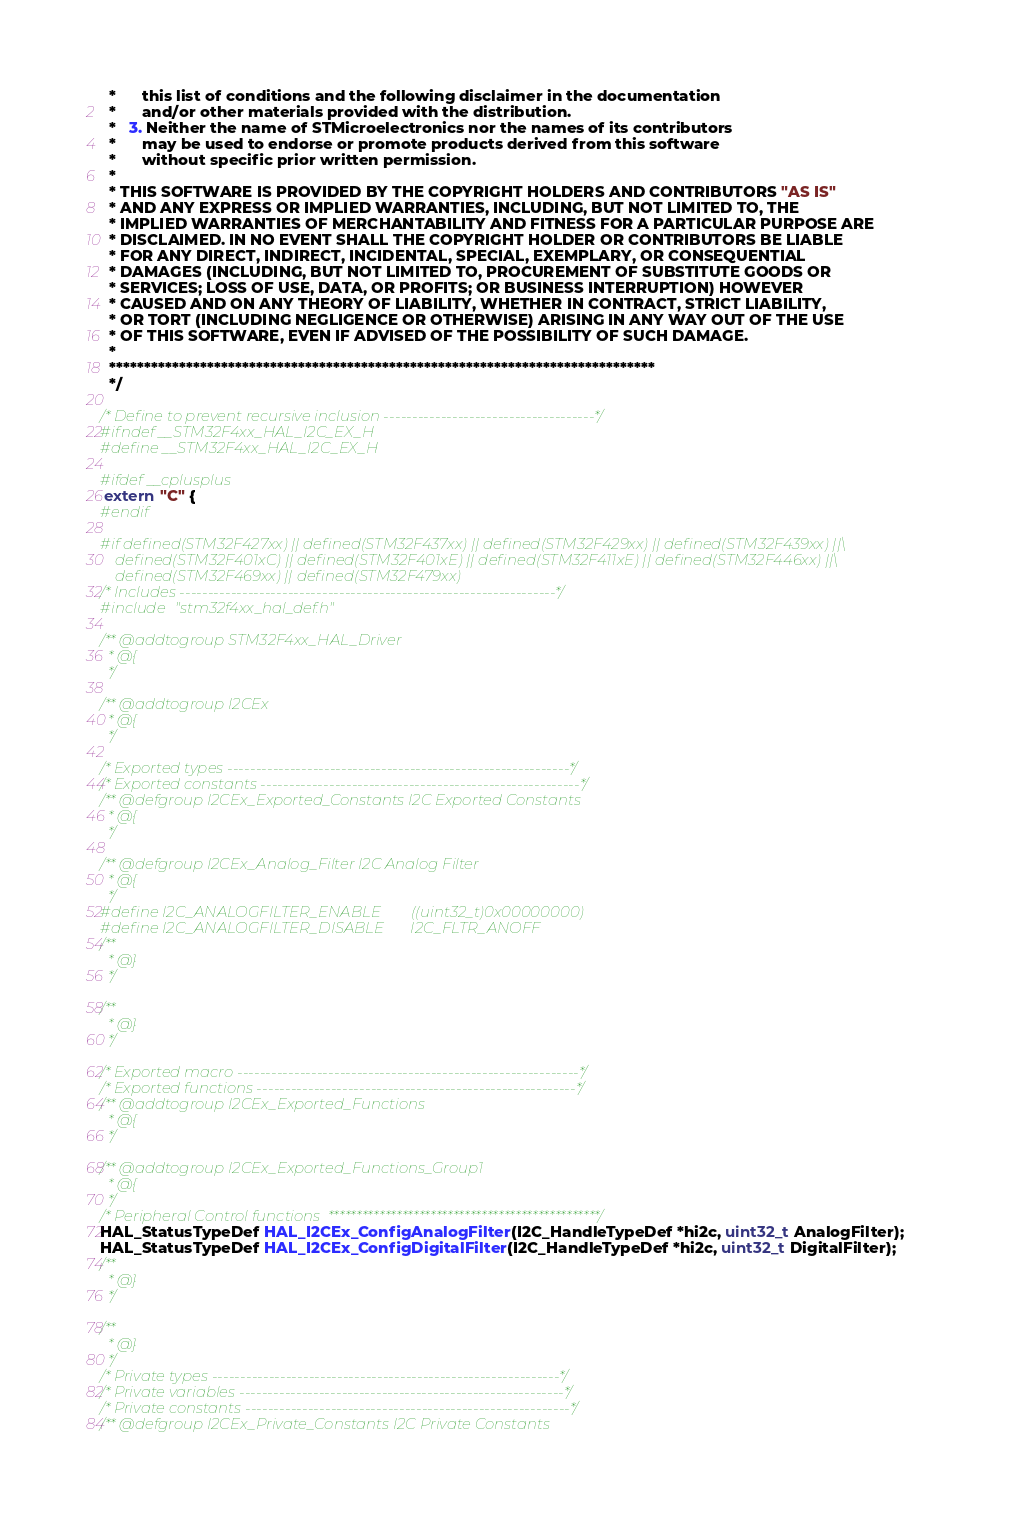Convert code to text. <code><loc_0><loc_0><loc_500><loc_500><_C_>  *      this list of conditions and the following disclaimer in the documentation
  *      and/or other materials provided with the distribution.
  *   3. Neither the name of STMicroelectronics nor the names of its contributors
  *      may be used to endorse or promote products derived from this software
  *      without specific prior written permission.
  *
  * THIS SOFTWARE IS PROVIDED BY THE COPYRIGHT HOLDERS AND CONTRIBUTORS "AS IS"
  * AND ANY EXPRESS OR IMPLIED WARRANTIES, INCLUDING, BUT NOT LIMITED TO, THE
  * IMPLIED WARRANTIES OF MERCHANTABILITY AND FITNESS FOR A PARTICULAR PURPOSE ARE
  * DISCLAIMED. IN NO EVENT SHALL THE COPYRIGHT HOLDER OR CONTRIBUTORS BE LIABLE
  * FOR ANY DIRECT, INDIRECT, INCIDENTAL, SPECIAL, EXEMPLARY, OR CONSEQUENTIAL
  * DAMAGES (INCLUDING, BUT NOT LIMITED TO, PROCUREMENT OF SUBSTITUTE GOODS OR
  * SERVICES; LOSS OF USE, DATA, OR PROFITS; OR BUSINESS INTERRUPTION) HOWEVER
  * CAUSED AND ON ANY THEORY OF LIABILITY, WHETHER IN CONTRACT, STRICT LIABILITY,
  * OR TORT (INCLUDING NEGLIGENCE OR OTHERWISE) ARISING IN ANY WAY OUT OF THE USE
  * OF THIS SOFTWARE, EVEN IF ADVISED OF THE POSSIBILITY OF SUCH DAMAGE.
  *
  ******************************************************************************
  */ 

/* Define to prevent recursive inclusion -------------------------------------*/
#ifndef __STM32F4xx_HAL_I2C_EX_H
#define __STM32F4xx_HAL_I2C_EX_H

#ifdef __cplusplus
 extern "C" {
#endif

#if defined(STM32F427xx) || defined(STM32F437xx) || defined(STM32F429xx) || defined(STM32F439xx) ||\
    defined(STM32F401xC) || defined(STM32F401xE) || defined(STM32F411xE) || defined(STM32F446xx) ||\
    defined(STM32F469xx) || defined(STM32F479xx)
/* Includes ------------------------------------------------------------------*/
#include "stm32f4xx_hal_def.h"  

/** @addtogroup STM32F4xx_HAL_Driver
  * @{
  */

/** @addtogroup I2CEx
  * @{
  */ 

/* Exported types ------------------------------------------------------------*/ 
/* Exported constants --------------------------------------------------------*/
/** @defgroup I2CEx_Exported_Constants I2C Exported Constants
  * @{
  */

/** @defgroup I2CEx_Analog_Filter I2C Analog Filter
  * @{
  */
#define I2C_ANALOGFILTER_ENABLE        ((uint32_t)0x00000000)
#define I2C_ANALOGFILTER_DISABLE       I2C_FLTR_ANOFF
/**
  * @}
  */
  
/**
  * @}
  */ 
  
/* Exported macro ------------------------------------------------------------*/
/* Exported functions --------------------------------------------------------*/
/** @addtogroup I2CEx_Exported_Functions
  * @{
  */

/** @addtogroup I2CEx_Exported_Functions_Group1
  * @{
  */
/* Peripheral Control functions  ************************************************/
HAL_StatusTypeDef HAL_I2CEx_ConfigAnalogFilter(I2C_HandleTypeDef *hi2c, uint32_t AnalogFilter);
HAL_StatusTypeDef HAL_I2CEx_ConfigDigitalFilter(I2C_HandleTypeDef *hi2c, uint32_t DigitalFilter);
/**
  * @}
  */

/**
  * @}
  */ 
/* Private types -------------------------------------------------------------*/
/* Private variables ---------------------------------------------------------*/
/* Private constants ---------------------------------------------------------*/
/** @defgroup I2CEx_Private_Constants I2C Private Constants</code> 